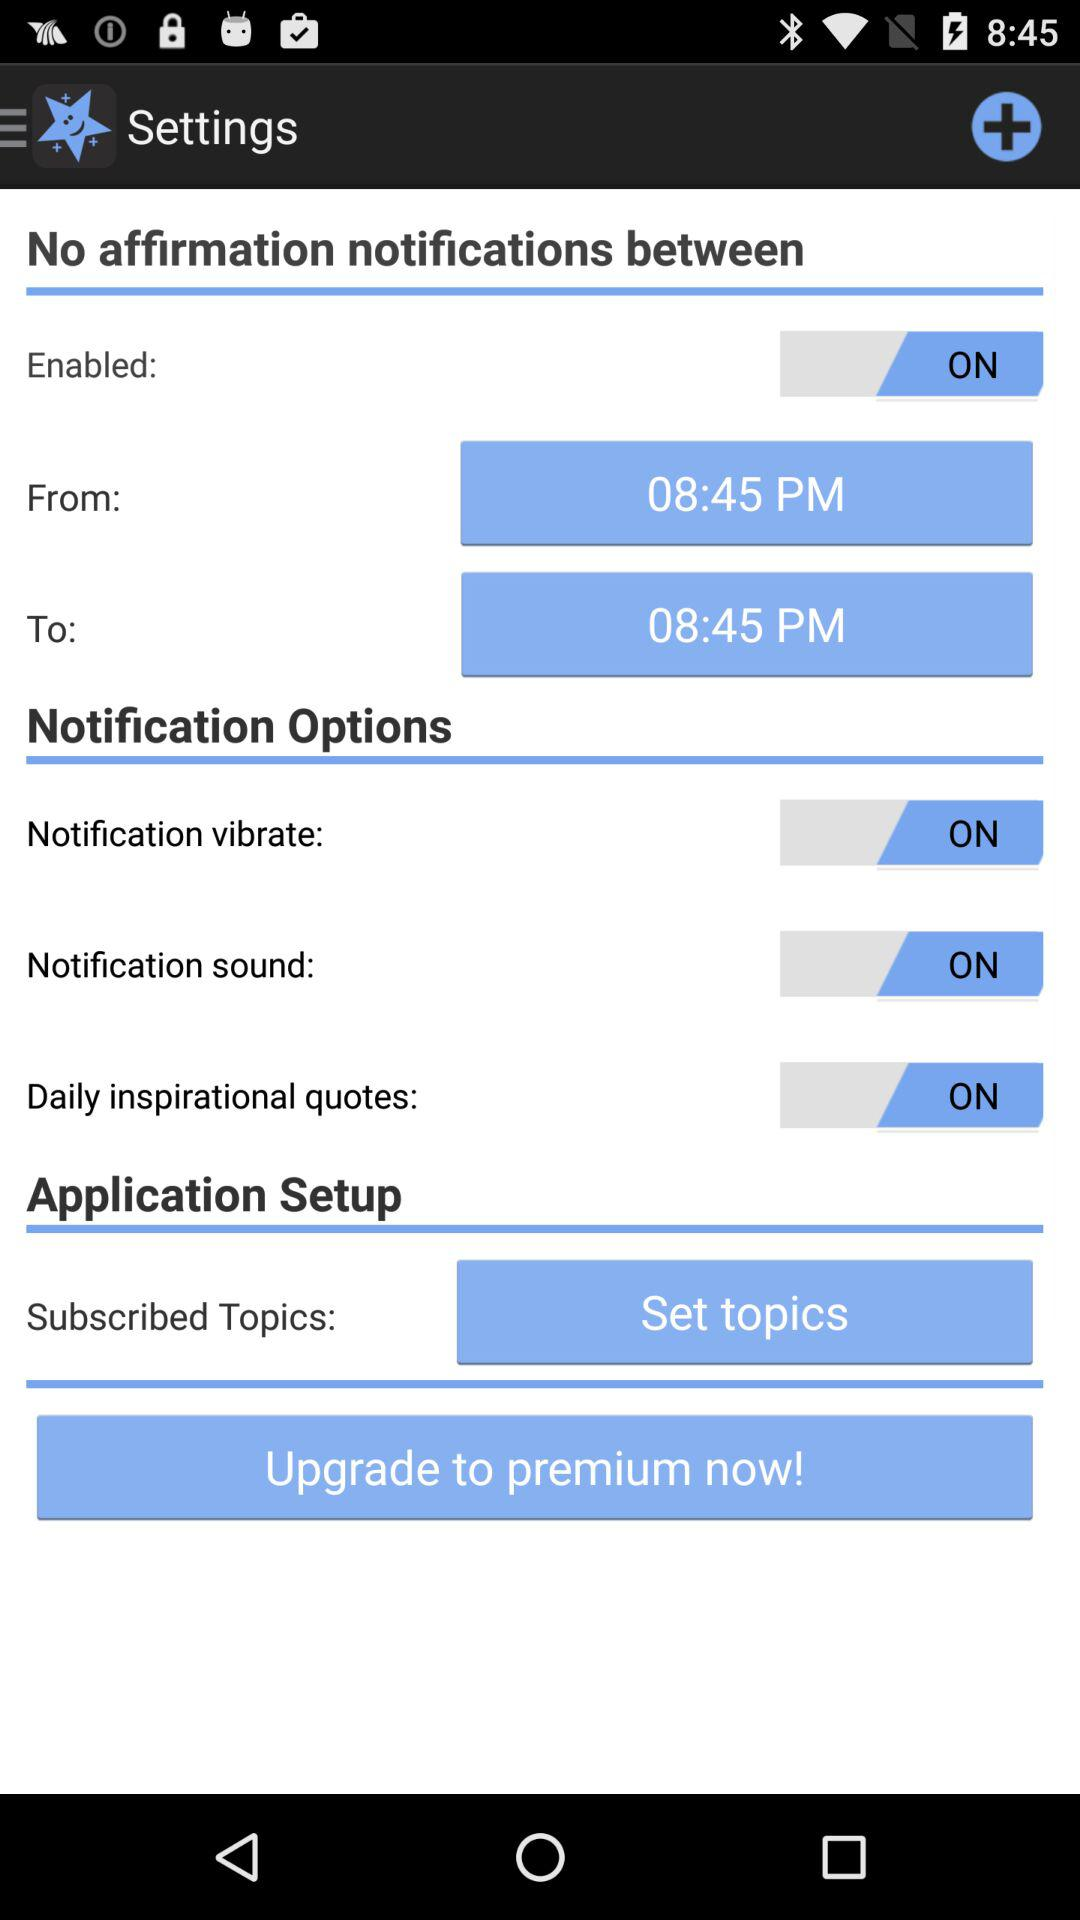What is the start time for no affirmation notification? The start time for no affirmation notification is 08:45 PM. 